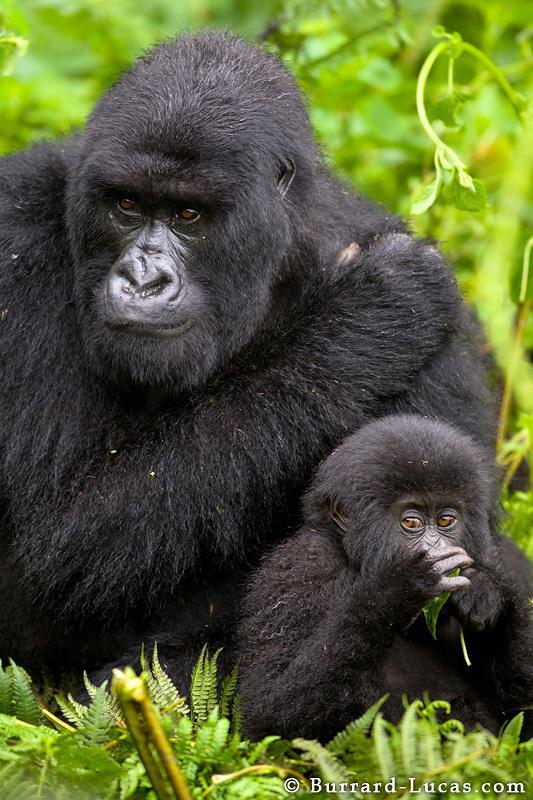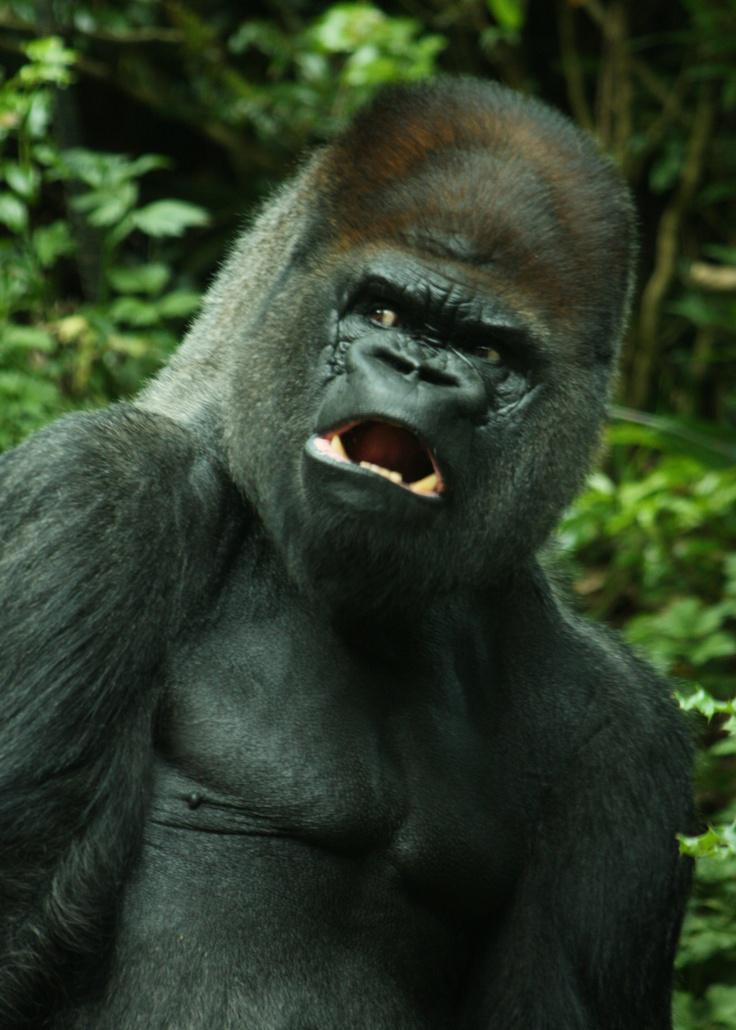The first image is the image on the left, the second image is the image on the right. For the images shown, is this caption "In one of the image there is a baby gorilla next to an adult gorilla." true? Answer yes or no. Yes. The first image is the image on the left, the second image is the image on the right. Analyze the images presented: Is the assertion "At least one image has a gorilla with an open mouth." valid? Answer yes or no. Yes. 